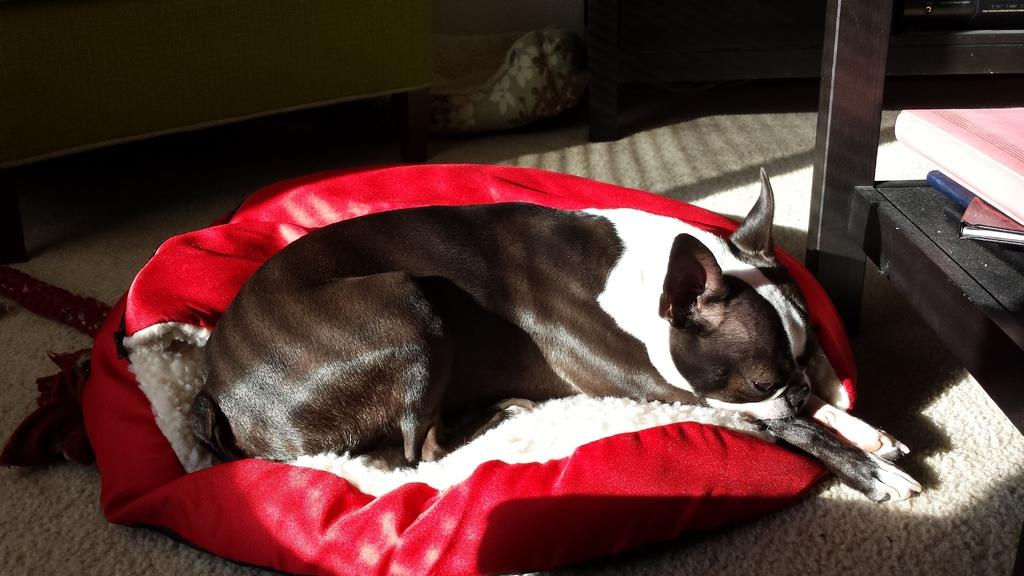What type of animal is present in the image? There is a dog in the image. What is the dog lying on? The dog is lying on a red object. What material is used for the objects in the image? There are wooden objects in the image. Can you describe any other items visible in the image? There are other items visible in the image, but their specific details are not mentioned in the provided facts. What color is the robin in the image? There is no robin present in the image. How does the question mark in the image look like? There is no question mark visible in the image. 